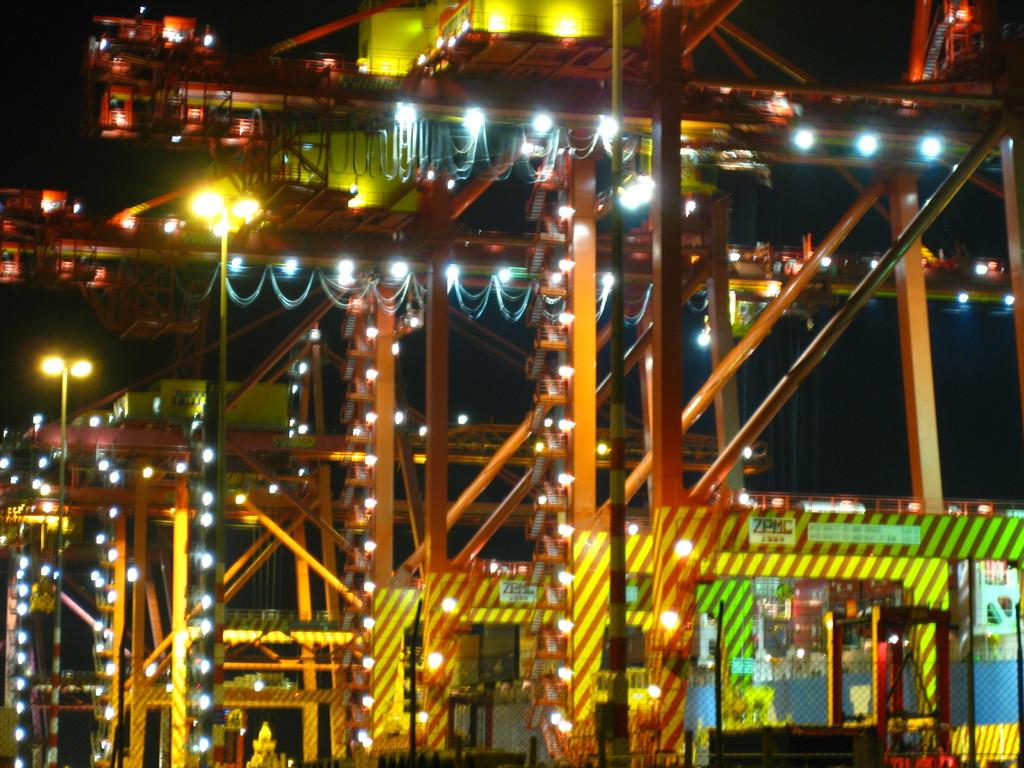What is attached to the poles in the image? There are lights attached to poles in the image. What structure can be seen in the image? There is a bridge in the image. What is the color of the background in the image? The background of the image is dark in color. What type of station is visible in the image? There is no station present in the image. How are the lights powered in the image? The image does not provide information about how the lights are powered. 